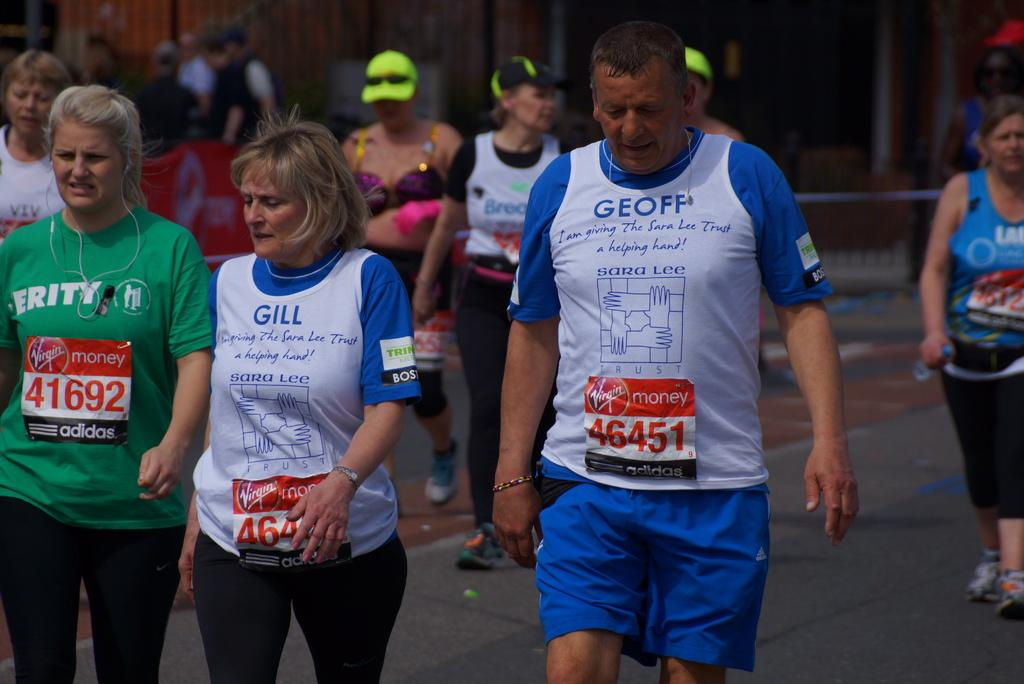<image>
Present a compact description of the photo's key features. A group of people are participating in a marathon and one of their shirts says Gill. 